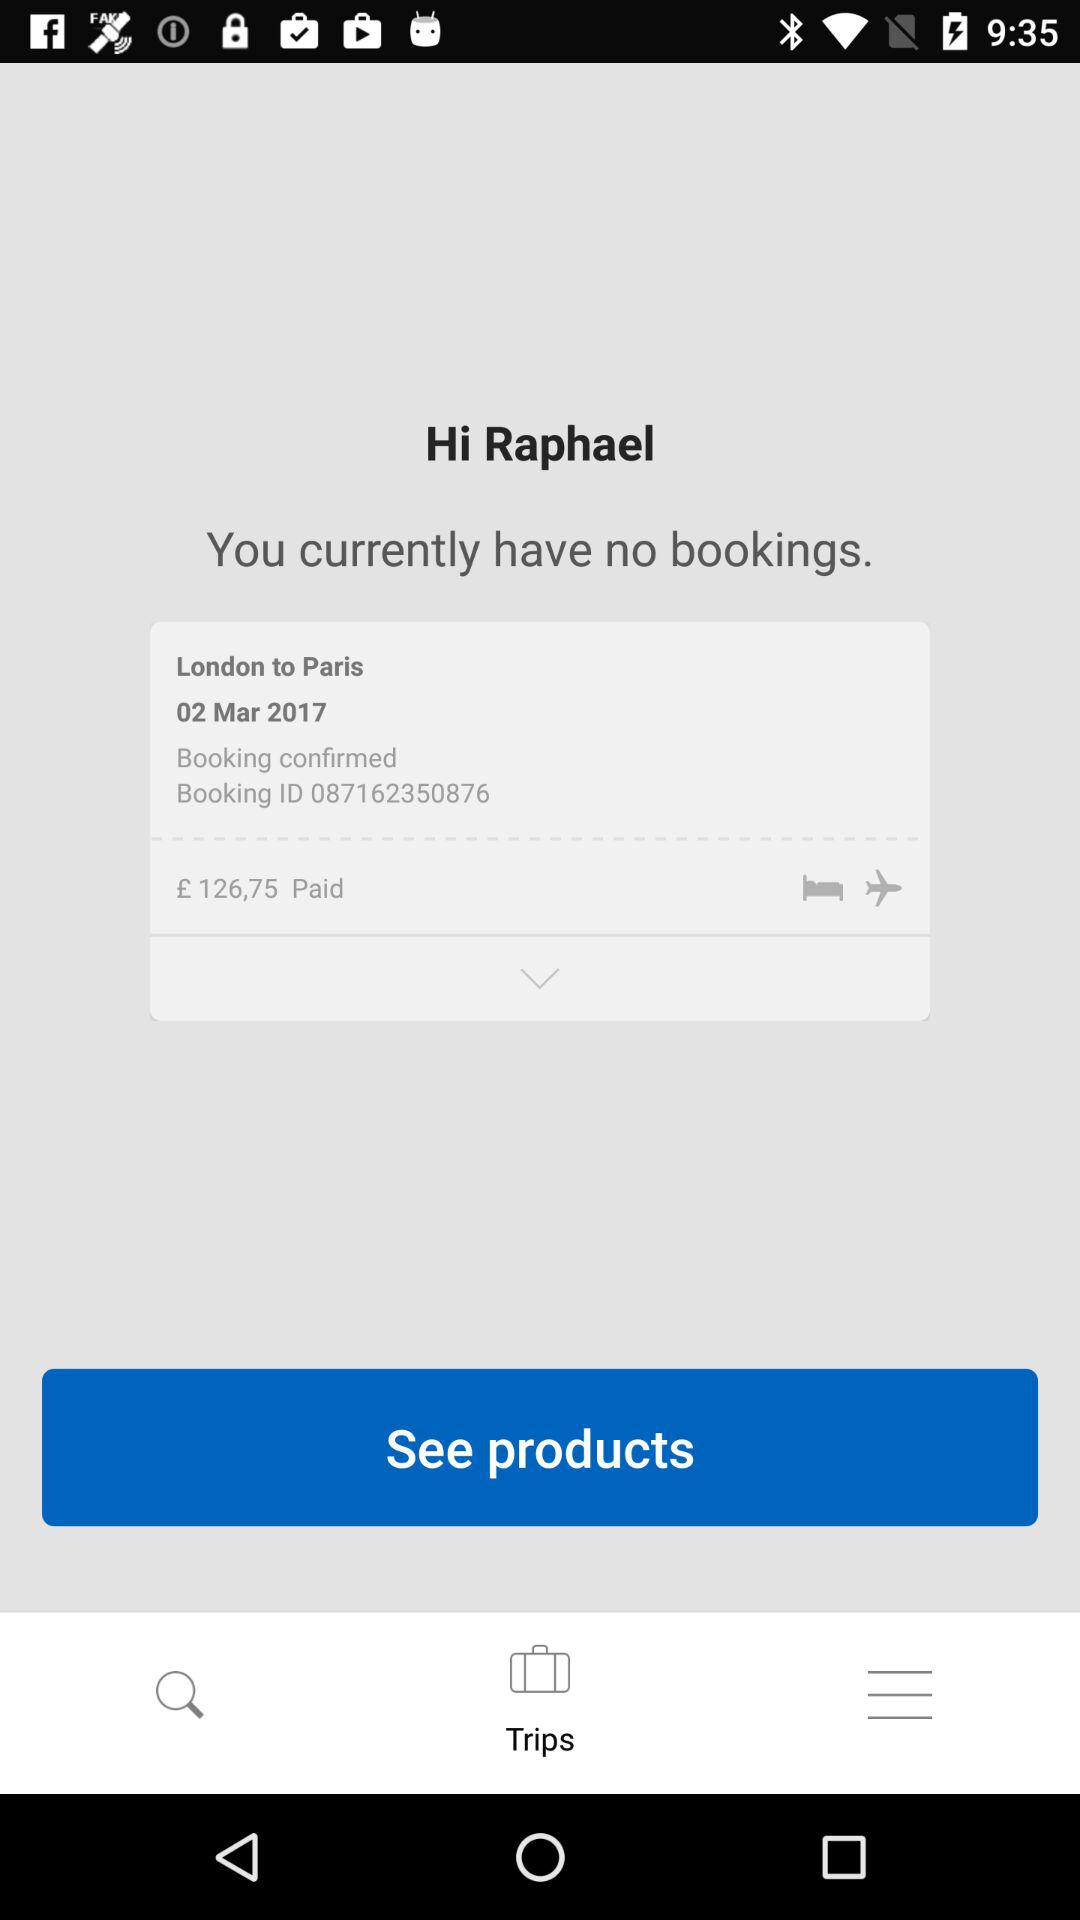What was the price of the last booking? The price of the last booking was £ 126,75. 